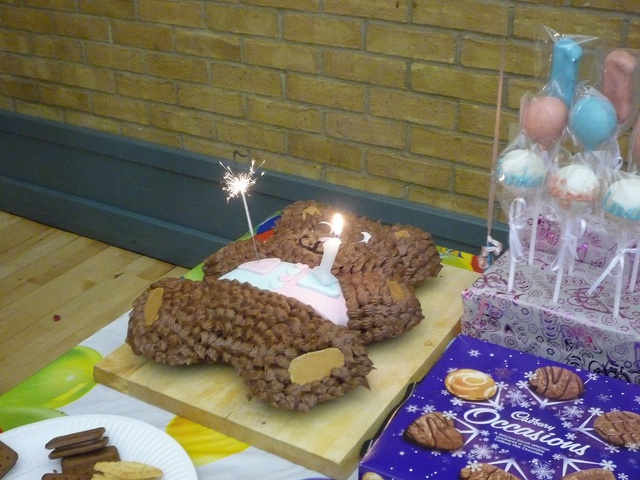Describe the objects in this image and their specific colors. I can see dining table in black, lightgray, maroon, gray, and tan tones, teddy bear in black, maroon, gray, and lightgray tones, and cake in black, lavender, gray, and darkgray tones in this image. 